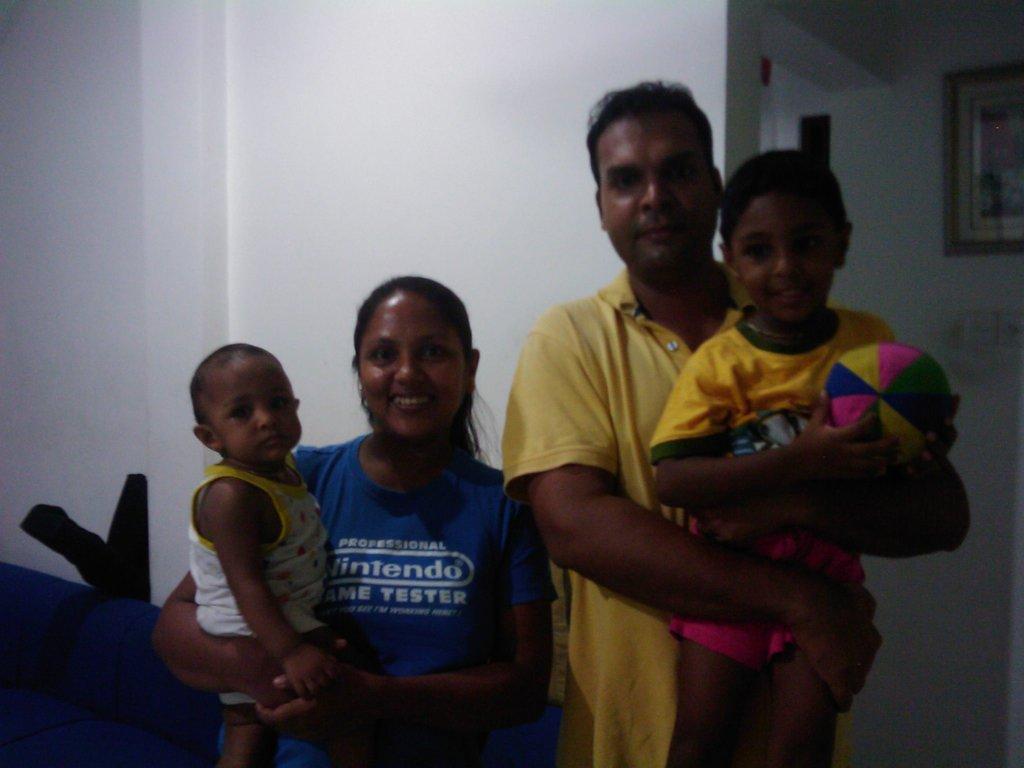Can you describe this image briefly? A couple is standing holding 2 children. A boy at the right is holding a ball. There is a white wall at the back and there is a photo frame at the right back. 